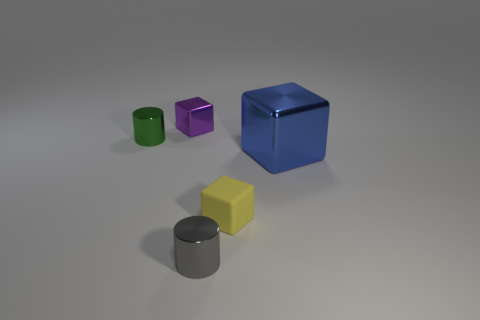Add 1 gray spheres. How many objects exist? 6 Subtract all cubes. How many objects are left? 2 Subtract all tiny purple blocks. How many blocks are left? 2 Subtract 2 cubes. How many cubes are left? 1 Subtract all green blocks. How many cyan cylinders are left? 0 Subtract all green shiny things. Subtract all large blue metal blocks. How many objects are left? 3 Add 3 metallic cylinders. How many metallic cylinders are left? 5 Add 1 cyan rubber cylinders. How many cyan rubber cylinders exist? 1 Subtract all yellow blocks. How many blocks are left? 2 Subtract 1 purple blocks. How many objects are left? 4 